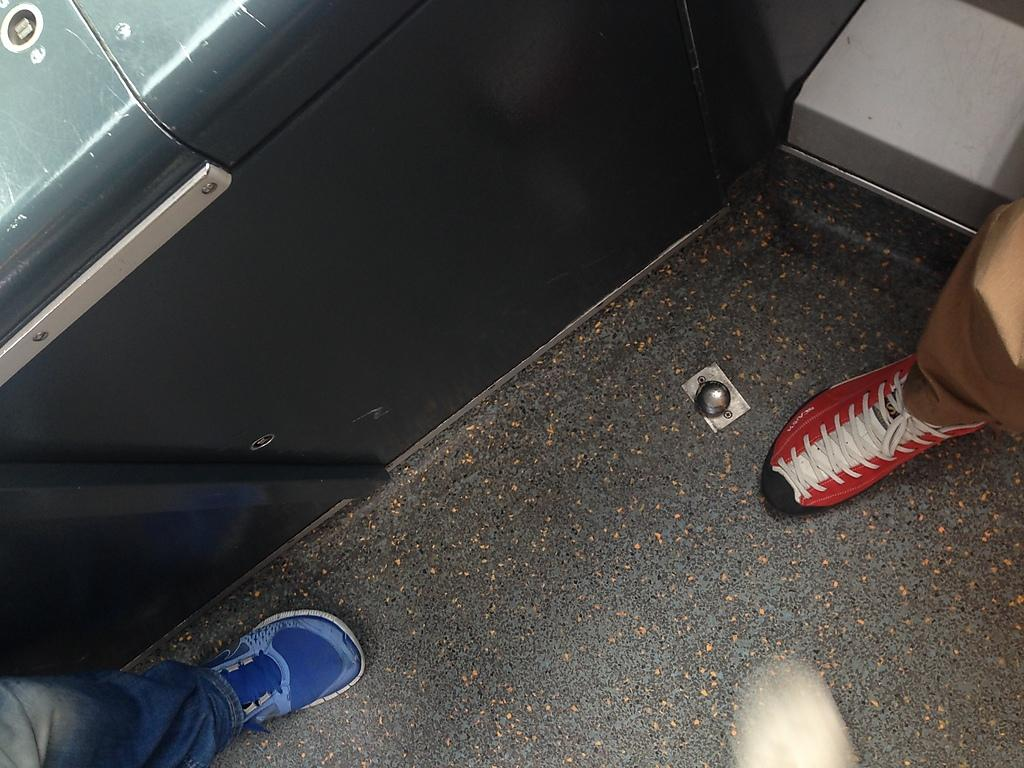What can be seen at the bottom of the image? There is a floor at the bottom of the image. What else is visible in the image besides the floor? Legs of people are visible in the image. Can you see any fog in the image? There is no fog visible in the image. Is there a store present in the image? There is no store visible in the image. 